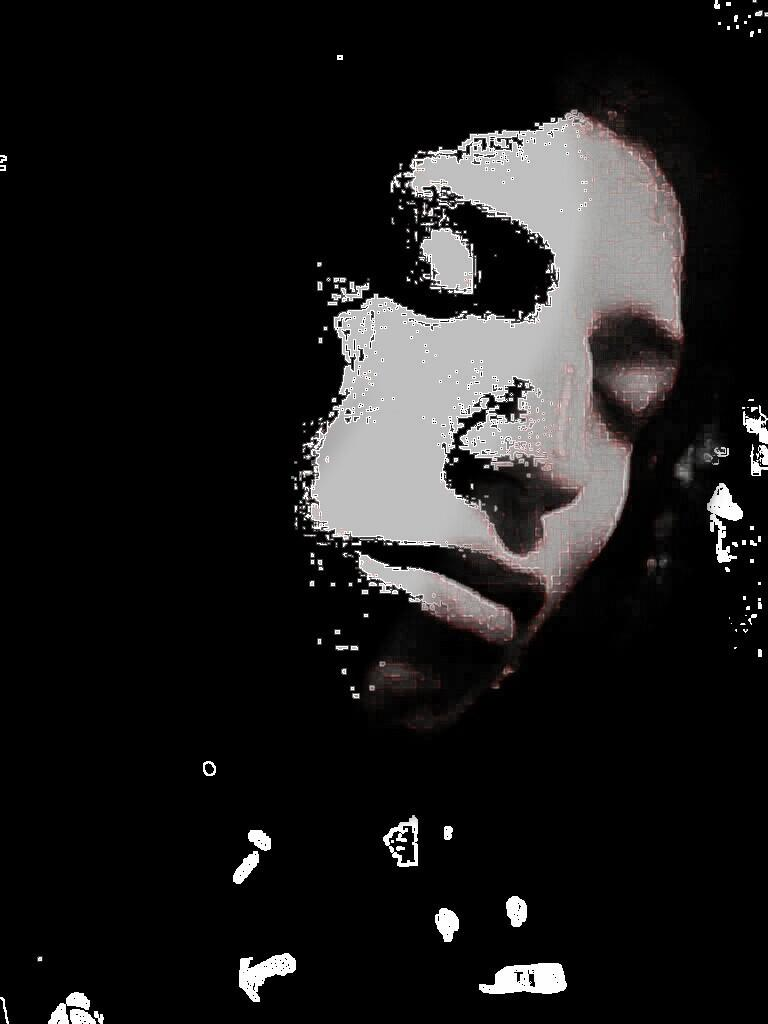What is the main subject of the image? There is a human face in the image. What color is the human face? The human face is white in color. What color is the background of the image? The background of the image is black. What type of bear can be seen wearing a sweater in the image? There is no bear or sweater present in the image; it features a human face on a black background. 